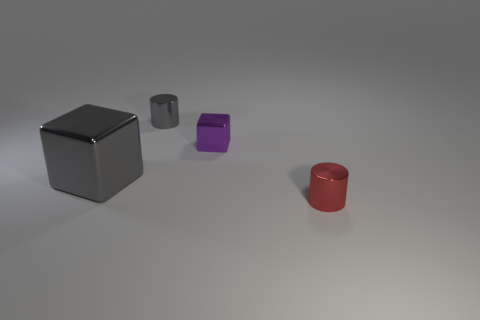Subtract all purple blocks. How many blocks are left? 1 Subtract 2 cubes. How many cubes are left? 0 Add 2 tiny gray metal cylinders. How many objects exist? 6 Subtract all large things. Subtract all tiny cubes. How many objects are left? 2 Add 2 tiny gray metal cylinders. How many tiny gray metal cylinders are left? 3 Add 1 tiny cubes. How many tiny cubes exist? 2 Subtract 0 red spheres. How many objects are left? 4 Subtract all red blocks. Subtract all yellow spheres. How many blocks are left? 2 